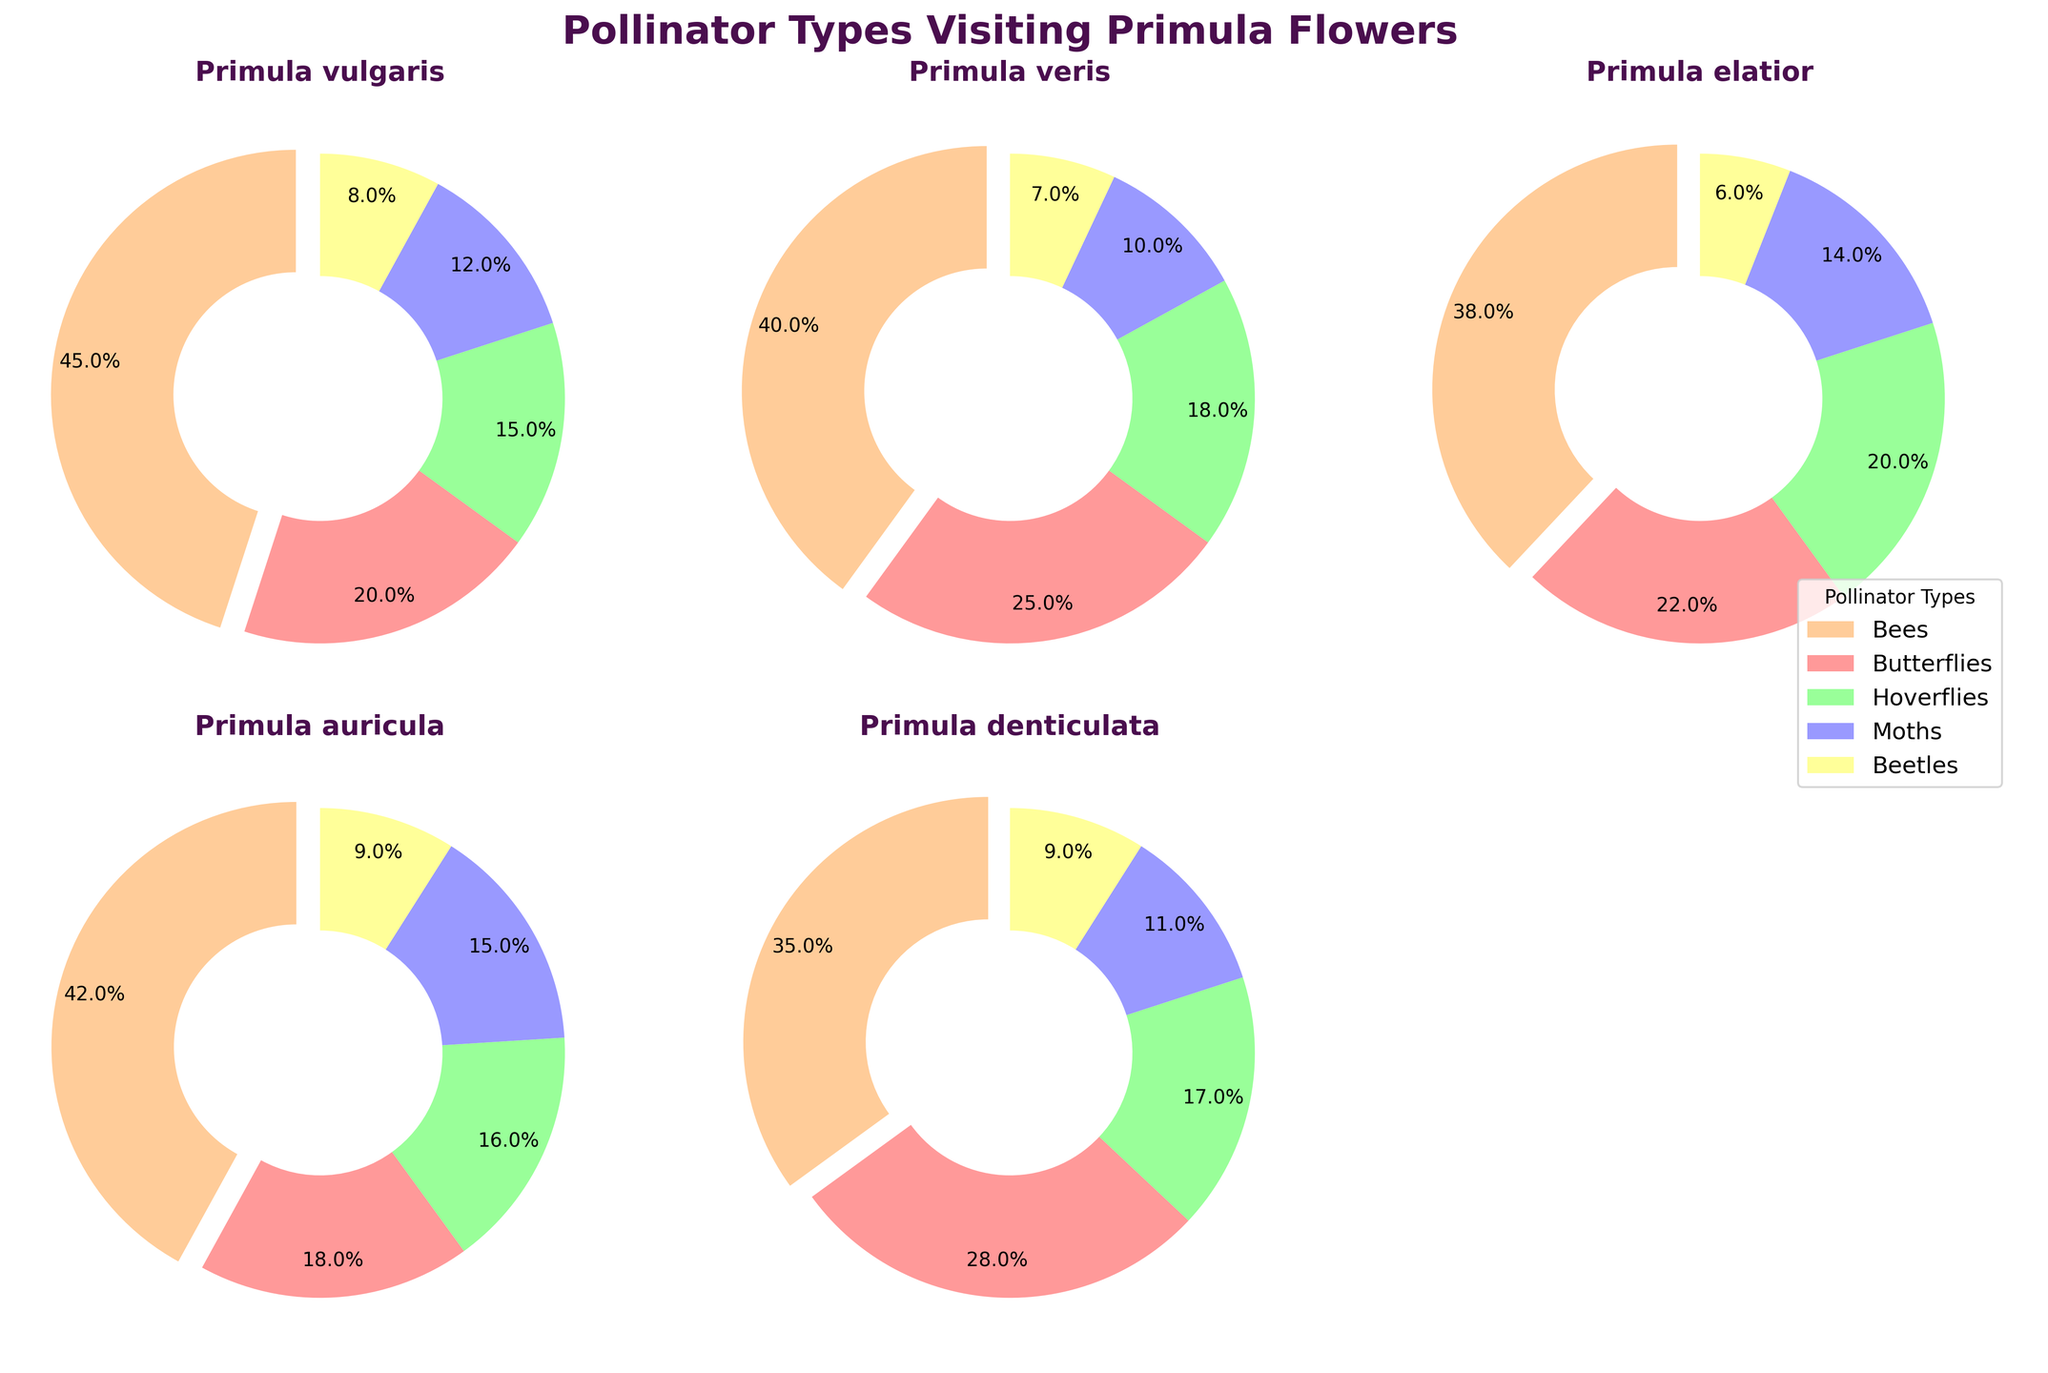What's the title of the figure? The title is typically placed at the top of a figure. For this figure, it is written in bold and includes keywords about the content of the figure.
Answer: Pollinator Types Visiting Primula Flowers What are the different segments of the pie charts colored? Each segment in the pie charts represents a specific pollinator type, and each type has a unique color.
Answer: Bees, Butterflies, Hoverflies, Moths, Beetles Which Primula species has the highest percentage of bee visits? To find this, look for the pie chart segment labeled 'Bees' and compare their sizes across all species.
Answer: Primula vulgaris What is the sum of beetle visits for all Primula species shown? To determine the sum, add the percentages of beetle visits from each pie chart. The values are given in the dataset: 8 (Primula vulgaris), 7 (Primula veris), 6 (Primula elatior), 9 (Primula auricula), and 9 (Primula denticulata).
Answer: 39 Which two species have the closest proportion of hoverfly visits? Compare the segments labeled 'Hoverflies' in each pie chart and identify those with the closest values.
Answer: Primula veris and Primula denticulata What is the difference in moth visit proportions between Primula elatior and Primula auricula? Find the segments for 'Moths' in both pie charts and subtract Primula auricula's percentage from Primula elatior's percentage: 15 - 14.
Answer: 1% Which species has the smallest proportion of butterfly visits? To identify this, compare the 'Butterflies' segments across all pie charts and find the smallest percentage.
Answer: Primula auricula Among all Primula species, which pollinator type has the lowest overall proportion? Analyze the sizes of segments across all pie charts and find the pollinator type that appears the smallest or least frequently.
Answer: Beetles If you sum the proportions of butterflies and hoverflies visiting Primula veris, what do you get? Add the proportions for 'Butterflies' and 'Hoverflies' in the Primula veris pie chart: 25 + 18.
Answer: 43% Which Primula species has the most evenly distributed proportions of all pollinator visits? An indication of even distribution is when all pie segments are roughly equal in size. Compare the pies to find the most balanced one.
Answer: Primula elatior 